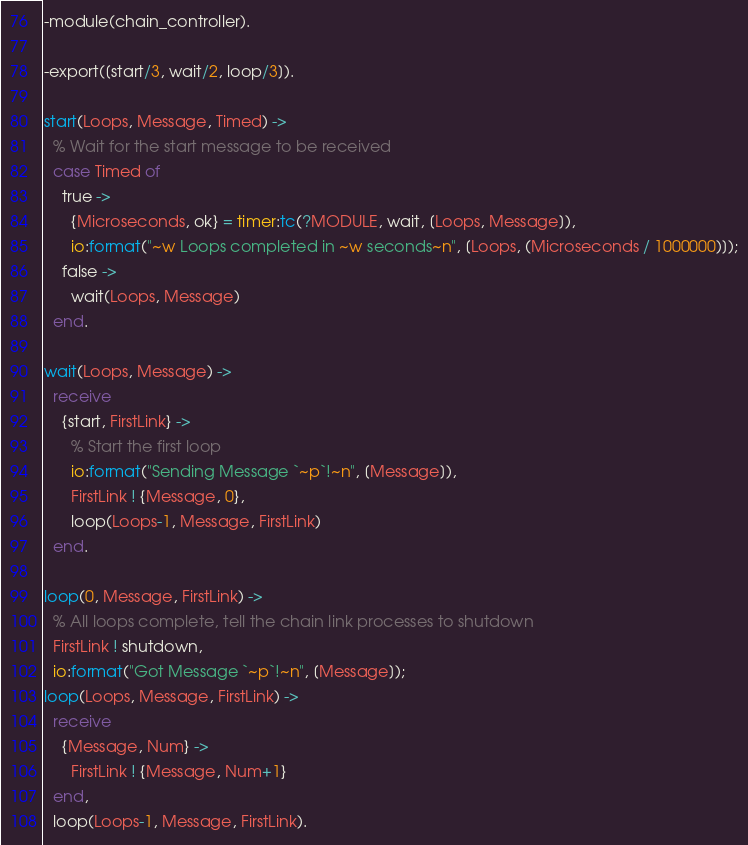<code> <loc_0><loc_0><loc_500><loc_500><_Erlang_>-module(chain_controller).

-export([start/3, wait/2, loop/3]).

start(Loops, Message, Timed) ->
  % Wait for the start message to be received
  case Timed of
    true ->
      {Microseconds, ok} = timer:tc(?MODULE, wait, [Loops, Message]),
      io:format("~w Loops completed in ~w seconds~n", [Loops, (Microseconds / 1000000)]);
    false ->
      wait(Loops, Message)
  end.

wait(Loops, Message) ->
  receive
    {start, FirstLink} ->
      % Start the first loop
      io:format("Sending Message `~p`!~n", [Message]),
      FirstLink ! {Message, 0},
      loop(Loops-1, Message, FirstLink)
  end.

loop(0, Message, FirstLink) ->
  % All loops complete, tell the chain link processes to shutdown
  FirstLink ! shutdown,
  io:format("Got Message `~p`!~n", [Message]);
loop(Loops, Message, FirstLink) ->
  receive
    {Message, Num} ->
      FirstLink ! {Message, Num+1}
  end,
  loop(Loops-1, Message, FirstLink).
</code> 